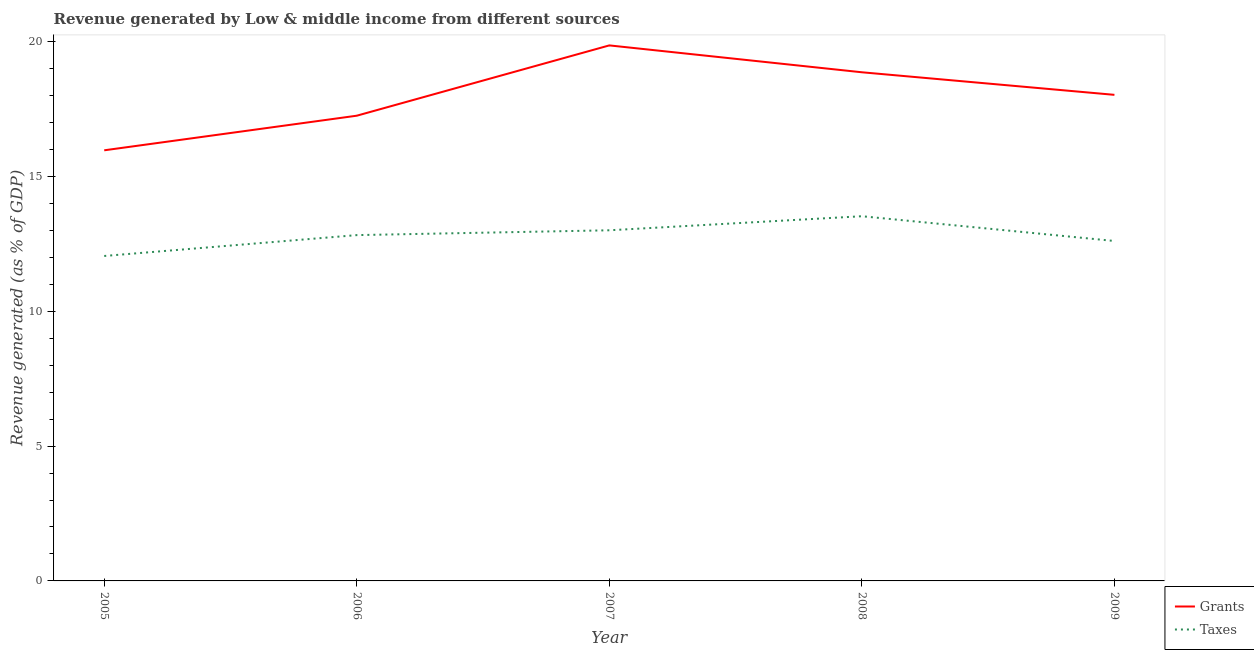How many different coloured lines are there?
Your answer should be very brief. 2. Does the line corresponding to revenue generated by taxes intersect with the line corresponding to revenue generated by grants?
Keep it short and to the point. No. Is the number of lines equal to the number of legend labels?
Your answer should be compact. Yes. What is the revenue generated by grants in 2006?
Your answer should be compact. 17.25. Across all years, what is the maximum revenue generated by taxes?
Your answer should be very brief. 13.52. Across all years, what is the minimum revenue generated by grants?
Provide a short and direct response. 15.97. In which year was the revenue generated by grants minimum?
Your response must be concise. 2005. What is the total revenue generated by taxes in the graph?
Your answer should be compact. 64.01. What is the difference between the revenue generated by taxes in 2006 and that in 2007?
Give a very brief answer. -0.18. What is the difference between the revenue generated by grants in 2007 and the revenue generated by taxes in 2005?
Keep it short and to the point. 7.81. What is the average revenue generated by taxes per year?
Give a very brief answer. 12.8. In the year 2006, what is the difference between the revenue generated by grants and revenue generated by taxes?
Ensure brevity in your answer.  4.43. What is the ratio of the revenue generated by taxes in 2006 to that in 2009?
Make the answer very short. 1.02. Is the difference between the revenue generated by grants in 2007 and 2009 greater than the difference between the revenue generated by taxes in 2007 and 2009?
Provide a succinct answer. Yes. What is the difference between the highest and the second highest revenue generated by taxes?
Keep it short and to the point. 0.52. What is the difference between the highest and the lowest revenue generated by taxes?
Offer a terse response. 1.47. In how many years, is the revenue generated by grants greater than the average revenue generated by grants taken over all years?
Provide a short and direct response. 3. Is the sum of the revenue generated by taxes in 2007 and 2008 greater than the maximum revenue generated by grants across all years?
Your response must be concise. Yes. Is the revenue generated by taxes strictly greater than the revenue generated by grants over the years?
Ensure brevity in your answer.  No. Is the revenue generated by grants strictly less than the revenue generated by taxes over the years?
Make the answer very short. No. How many years are there in the graph?
Offer a very short reply. 5. Does the graph contain any zero values?
Provide a short and direct response. No. Does the graph contain grids?
Offer a terse response. No. How many legend labels are there?
Your answer should be very brief. 2. How are the legend labels stacked?
Your response must be concise. Vertical. What is the title of the graph?
Your answer should be very brief. Revenue generated by Low & middle income from different sources. Does "Non-pregnant women" appear as one of the legend labels in the graph?
Your answer should be very brief. No. What is the label or title of the Y-axis?
Make the answer very short. Revenue generated (as % of GDP). What is the Revenue generated (as % of GDP) in Grants in 2005?
Give a very brief answer. 15.97. What is the Revenue generated (as % of GDP) in Taxes in 2005?
Provide a succinct answer. 12.05. What is the Revenue generated (as % of GDP) of Grants in 2006?
Provide a succinct answer. 17.25. What is the Revenue generated (as % of GDP) in Taxes in 2006?
Offer a very short reply. 12.82. What is the Revenue generated (as % of GDP) of Grants in 2007?
Your response must be concise. 19.86. What is the Revenue generated (as % of GDP) of Taxes in 2007?
Ensure brevity in your answer.  13. What is the Revenue generated (as % of GDP) of Grants in 2008?
Make the answer very short. 18.86. What is the Revenue generated (as % of GDP) of Taxes in 2008?
Offer a terse response. 13.52. What is the Revenue generated (as % of GDP) of Grants in 2009?
Provide a short and direct response. 18.02. What is the Revenue generated (as % of GDP) of Taxes in 2009?
Provide a short and direct response. 12.61. Across all years, what is the maximum Revenue generated (as % of GDP) in Grants?
Your response must be concise. 19.86. Across all years, what is the maximum Revenue generated (as % of GDP) of Taxes?
Keep it short and to the point. 13.52. Across all years, what is the minimum Revenue generated (as % of GDP) of Grants?
Your answer should be compact. 15.97. Across all years, what is the minimum Revenue generated (as % of GDP) of Taxes?
Make the answer very short. 12.05. What is the total Revenue generated (as % of GDP) in Grants in the graph?
Ensure brevity in your answer.  89.96. What is the total Revenue generated (as % of GDP) in Taxes in the graph?
Ensure brevity in your answer.  64. What is the difference between the Revenue generated (as % of GDP) of Grants in 2005 and that in 2006?
Provide a succinct answer. -1.28. What is the difference between the Revenue generated (as % of GDP) in Taxes in 2005 and that in 2006?
Your response must be concise. -0.77. What is the difference between the Revenue generated (as % of GDP) of Grants in 2005 and that in 2007?
Give a very brief answer. -3.89. What is the difference between the Revenue generated (as % of GDP) of Taxes in 2005 and that in 2007?
Offer a very short reply. -0.95. What is the difference between the Revenue generated (as % of GDP) of Grants in 2005 and that in 2008?
Offer a terse response. -2.89. What is the difference between the Revenue generated (as % of GDP) in Taxes in 2005 and that in 2008?
Ensure brevity in your answer.  -1.47. What is the difference between the Revenue generated (as % of GDP) in Grants in 2005 and that in 2009?
Your answer should be compact. -2.06. What is the difference between the Revenue generated (as % of GDP) in Taxes in 2005 and that in 2009?
Offer a terse response. -0.56. What is the difference between the Revenue generated (as % of GDP) in Grants in 2006 and that in 2007?
Provide a succinct answer. -2.61. What is the difference between the Revenue generated (as % of GDP) of Taxes in 2006 and that in 2007?
Your answer should be very brief. -0.18. What is the difference between the Revenue generated (as % of GDP) of Grants in 2006 and that in 2008?
Provide a short and direct response. -1.61. What is the difference between the Revenue generated (as % of GDP) in Taxes in 2006 and that in 2008?
Your answer should be compact. -0.7. What is the difference between the Revenue generated (as % of GDP) of Grants in 2006 and that in 2009?
Provide a succinct answer. -0.77. What is the difference between the Revenue generated (as % of GDP) in Taxes in 2006 and that in 2009?
Your answer should be compact. 0.22. What is the difference between the Revenue generated (as % of GDP) in Grants in 2007 and that in 2008?
Keep it short and to the point. 1. What is the difference between the Revenue generated (as % of GDP) of Taxes in 2007 and that in 2008?
Make the answer very short. -0.52. What is the difference between the Revenue generated (as % of GDP) in Grants in 2007 and that in 2009?
Give a very brief answer. 1.83. What is the difference between the Revenue generated (as % of GDP) in Taxes in 2007 and that in 2009?
Ensure brevity in your answer.  0.4. What is the difference between the Revenue generated (as % of GDP) in Grants in 2008 and that in 2009?
Give a very brief answer. 0.84. What is the difference between the Revenue generated (as % of GDP) in Taxes in 2008 and that in 2009?
Offer a very short reply. 0.92. What is the difference between the Revenue generated (as % of GDP) in Grants in 2005 and the Revenue generated (as % of GDP) in Taxes in 2006?
Make the answer very short. 3.14. What is the difference between the Revenue generated (as % of GDP) in Grants in 2005 and the Revenue generated (as % of GDP) in Taxes in 2007?
Give a very brief answer. 2.97. What is the difference between the Revenue generated (as % of GDP) in Grants in 2005 and the Revenue generated (as % of GDP) in Taxes in 2008?
Offer a terse response. 2.44. What is the difference between the Revenue generated (as % of GDP) of Grants in 2005 and the Revenue generated (as % of GDP) of Taxes in 2009?
Offer a very short reply. 3.36. What is the difference between the Revenue generated (as % of GDP) of Grants in 2006 and the Revenue generated (as % of GDP) of Taxes in 2007?
Provide a short and direct response. 4.25. What is the difference between the Revenue generated (as % of GDP) of Grants in 2006 and the Revenue generated (as % of GDP) of Taxes in 2008?
Your answer should be compact. 3.73. What is the difference between the Revenue generated (as % of GDP) of Grants in 2006 and the Revenue generated (as % of GDP) of Taxes in 2009?
Provide a short and direct response. 4.65. What is the difference between the Revenue generated (as % of GDP) of Grants in 2007 and the Revenue generated (as % of GDP) of Taxes in 2008?
Give a very brief answer. 6.33. What is the difference between the Revenue generated (as % of GDP) of Grants in 2007 and the Revenue generated (as % of GDP) of Taxes in 2009?
Your answer should be very brief. 7.25. What is the difference between the Revenue generated (as % of GDP) of Grants in 2008 and the Revenue generated (as % of GDP) of Taxes in 2009?
Offer a terse response. 6.26. What is the average Revenue generated (as % of GDP) of Grants per year?
Your response must be concise. 17.99. What is the average Revenue generated (as % of GDP) of Taxes per year?
Provide a short and direct response. 12.8. In the year 2005, what is the difference between the Revenue generated (as % of GDP) in Grants and Revenue generated (as % of GDP) in Taxes?
Offer a very short reply. 3.92. In the year 2006, what is the difference between the Revenue generated (as % of GDP) of Grants and Revenue generated (as % of GDP) of Taxes?
Provide a succinct answer. 4.43. In the year 2007, what is the difference between the Revenue generated (as % of GDP) in Grants and Revenue generated (as % of GDP) in Taxes?
Make the answer very short. 6.86. In the year 2008, what is the difference between the Revenue generated (as % of GDP) of Grants and Revenue generated (as % of GDP) of Taxes?
Provide a short and direct response. 5.34. In the year 2009, what is the difference between the Revenue generated (as % of GDP) of Grants and Revenue generated (as % of GDP) of Taxes?
Provide a succinct answer. 5.42. What is the ratio of the Revenue generated (as % of GDP) in Grants in 2005 to that in 2006?
Give a very brief answer. 0.93. What is the ratio of the Revenue generated (as % of GDP) in Taxes in 2005 to that in 2006?
Make the answer very short. 0.94. What is the ratio of the Revenue generated (as % of GDP) in Grants in 2005 to that in 2007?
Offer a terse response. 0.8. What is the ratio of the Revenue generated (as % of GDP) of Taxes in 2005 to that in 2007?
Provide a succinct answer. 0.93. What is the ratio of the Revenue generated (as % of GDP) of Grants in 2005 to that in 2008?
Your answer should be very brief. 0.85. What is the ratio of the Revenue generated (as % of GDP) in Taxes in 2005 to that in 2008?
Offer a terse response. 0.89. What is the ratio of the Revenue generated (as % of GDP) of Grants in 2005 to that in 2009?
Offer a terse response. 0.89. What is the ratio of the Revenue generated (as % of GDP) in Taxes in 2005 to that in 2009?
Provide a succinct answer. 0.96. What is the ratio of the Revenue generated (as % of GDP) in Grants in 2006 to that in 2007?
Make the answer very short. 0.87. What is the ratio of the Revenue generated (as % of GDP) of Taxes in 2006 to that in 2007?
Ensure brevity in your answer.  0.99. What is the ratio of the Revenue generated (as % of GDP) of Grants in 2006 to that in 2008?
Offer a terse response. 0.91. What is the ratio of the Revenue generated (as % of GDP) in Taxes in 2006 to that in 2008?
Keep it short and to the point. 0.95. What is the ratio of the Revenue generated (as % of GDP) in Grants in 2006 to that in 2009?
Give a very brief answer. 0.96. What is the ratio of the Revenue generated (as % of GDP) of Taxes in 2006 to that in 2009?
Provide a succinct answer. 1.02. What is the ratio of the Revenue generated (as % of GDP) of Grants in 2007 to that in 2008?
Ensure brevity in your answer.  1.05. What is the ratio of the Revenue generated (as % of GDP) of Taxes in 2007 to that in 2008?
Your response must be concise. 0.96. What is the ratio of the Revenue generated (as % of GDP) of Grants in 2007 to that in 2009?
Your response must be concise. 1.1. What is the ratio of the Revenue generated (as % of GDP) of Taxes in 2007 to that in 2009?
Your answer should be very brief. 1.03. What is the ratio of the Revenue generated (as % of GDP) in Grants in 2008 to that in 2009?
Your response must be concise. 1.05. What is the ratio of the Revenue generated (as % of GDP) in Taxes in 2008 to that in 2009?
Provide a short and direct response. 1.07. What is the difference between the highest and the second highest Revenue generated (as % of GDP) of Taxes?
Your answer should be compact. 0.52. What is the difference between the highest and the lowest Revenue generated (as % of GDP) in Grants?
Your answer should be very brief. 3.89. What is the difference between the highest and the lowest Revenue generated (as % of GDP) in Taxes?
Your response must be concise. 1.47. 